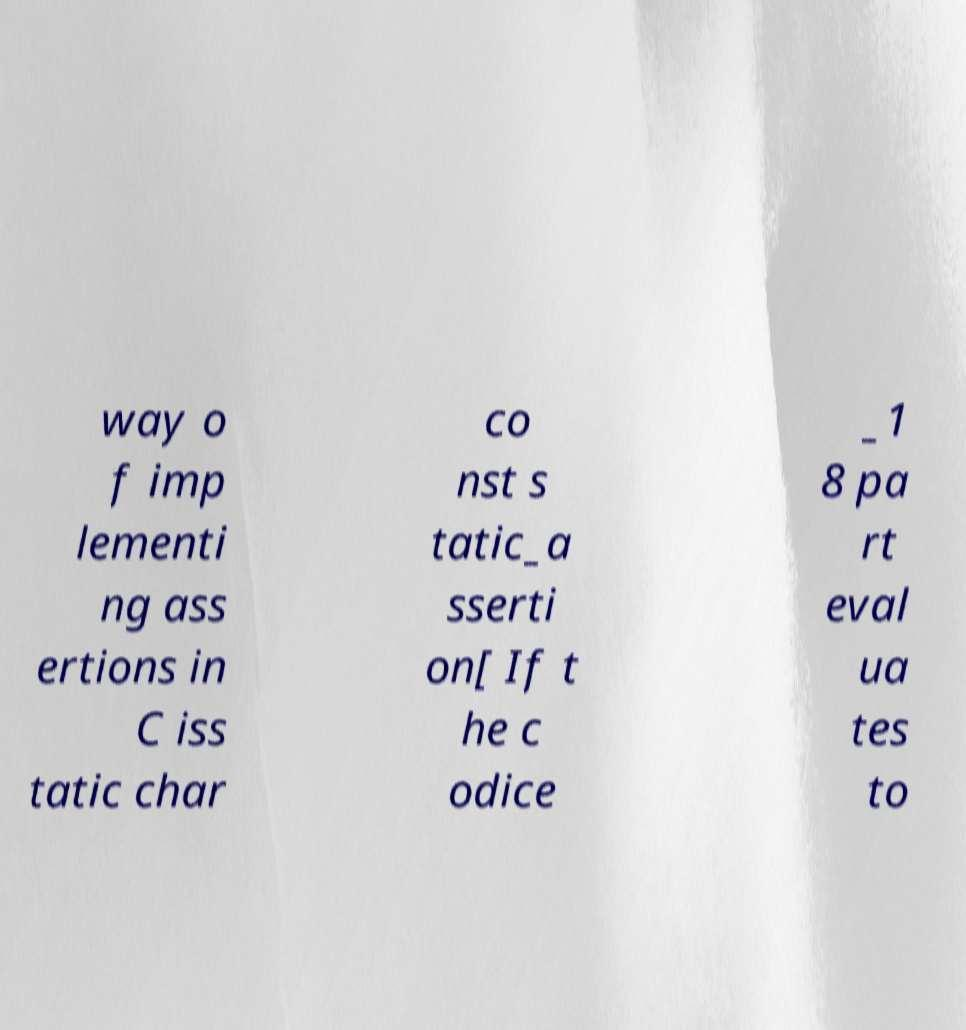Please read and relay the text visible in this image. What does it say? way o f imp lementi ng ass ertions in C iss tatic char co nst s tatic_a sserti on[ If t he c odice _1 8 pa rt eval ua tes to 